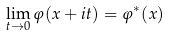Convert formula to latex. <formula><loc_0><loc_0><loc_500><loc_500>\lim _ { t \rightarrow 0 } \varphi ( x + i t ) = \varphi ^ { * } ( x )</formula> 